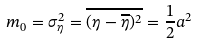<formula> <loc_0><loc_0><loc_500><loc_500>m _ { 0 } = \sigma _ { \eta } ^ { 2 } = \overline { ( \eta - \overline { \eta } ) ^ { 2 } } = \frac { 1 } { 2 } a ^ { 2 }</formula> 